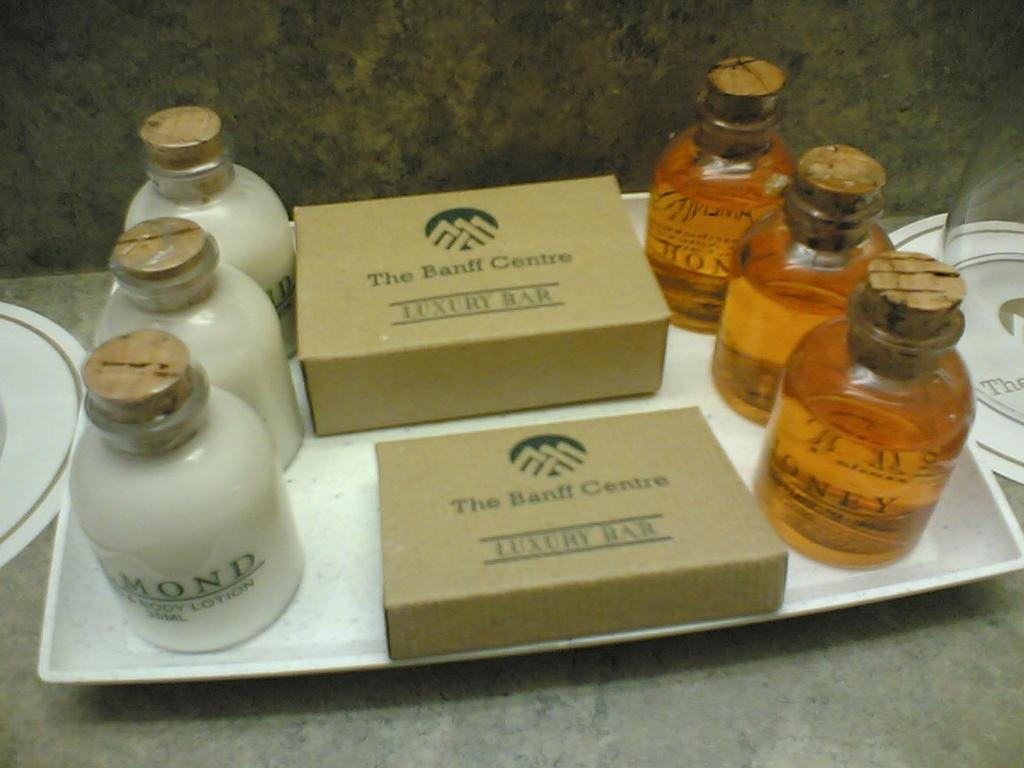<image>
Provide a brief description of the given image. A hotel essential bath and shower kit from the Banff Centre including a luxury bar, lotion, and soap. 